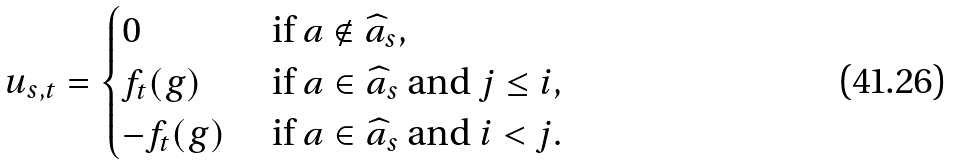Convert formula to latex. <formula><loc_0><loc_0><loc_500><loc_500>u _ { s , t } = \begin{cases} 0 & \text { if } a \notin \widehat { a } _ { s } , \\ f _ { t } ( g ) & \text { if } a \in \widehat { a } _ { s } \text { and } j \leq i , \\ - f _ { t } ( g ) & \text { if } a \in \widehat { a } _ { s } \text { and } i < j . \end{cases}</formula> 